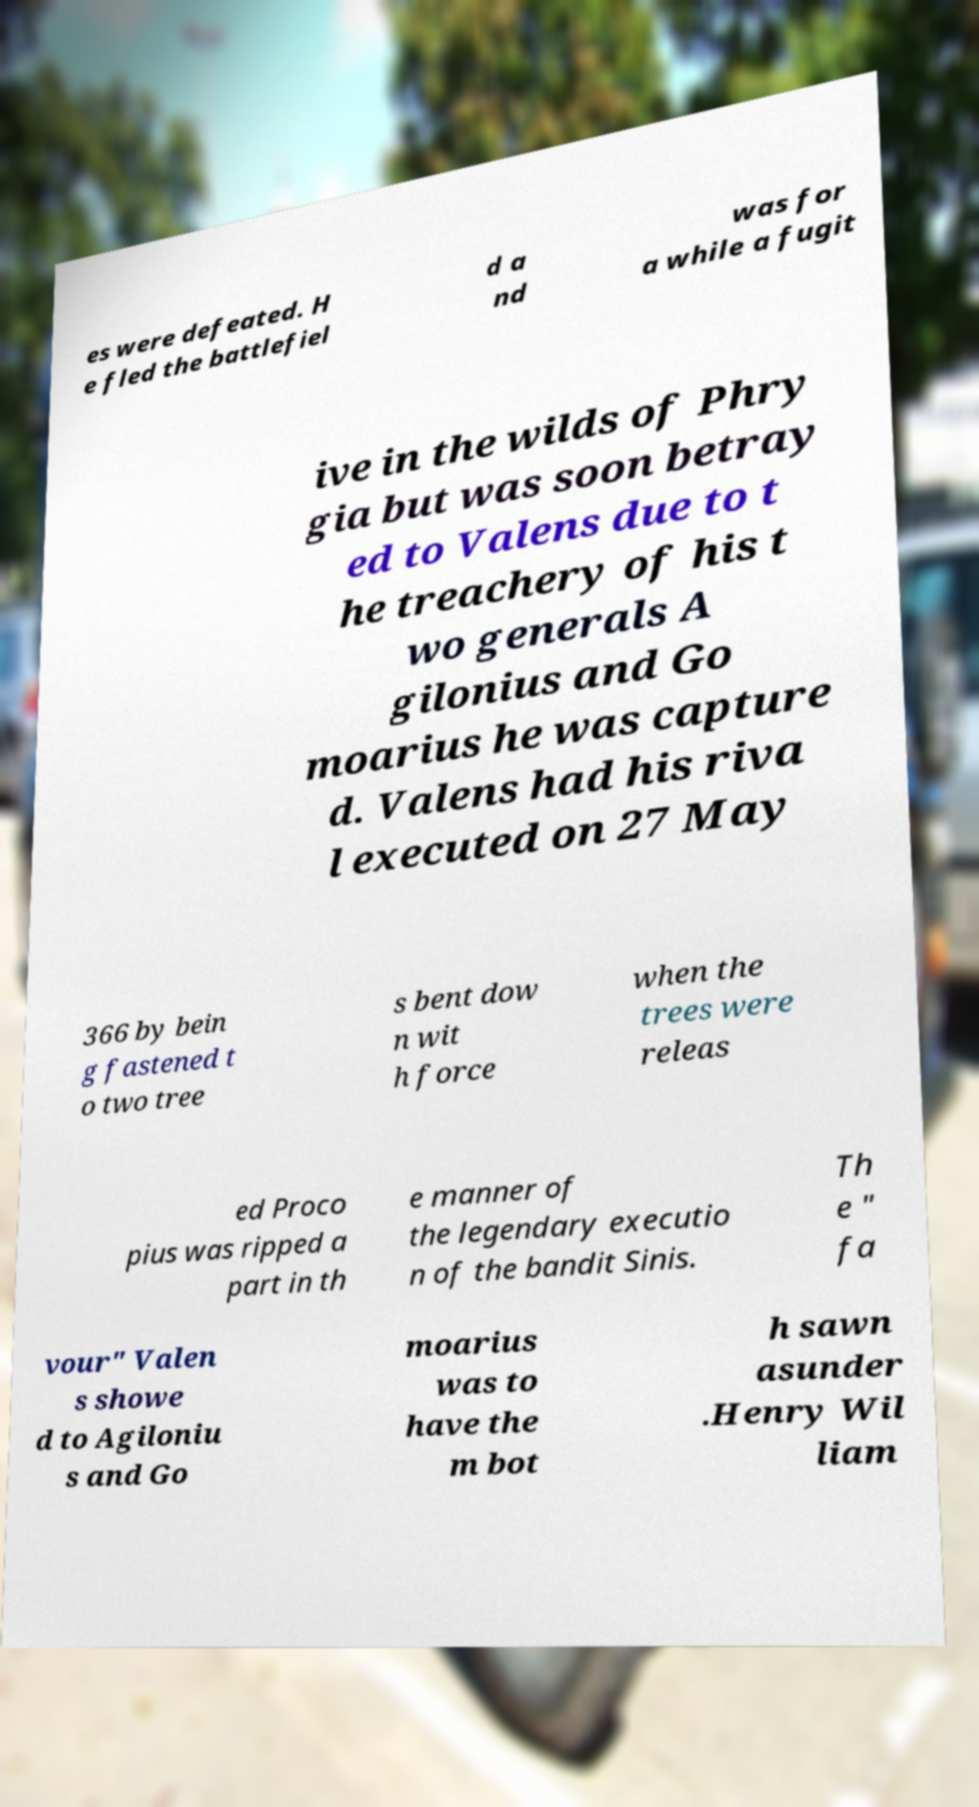Could you assist in decoding the text presented in this image and type it out clearly? es were defeated. H e fled the battlefiel d a nd was for a while a fugit ive in the wilds of Phry gia but was soon betray ed to Valens due to t he treachery of his t wo generals A gilonius and Go moarius he was capture d. Valens had his riva l executed on 27 May 366 by bein g fastened t o two tree s bent dow n wit h force when the trees were releas ed Proco pius was ripped a part in th e manner of the legendary executio n of the bandit Sinis. Th e " fa vour" Valen s showe d to Agiloniu s and Go moarius was to have the m bot h sawn asunder .Henry Wil liam 